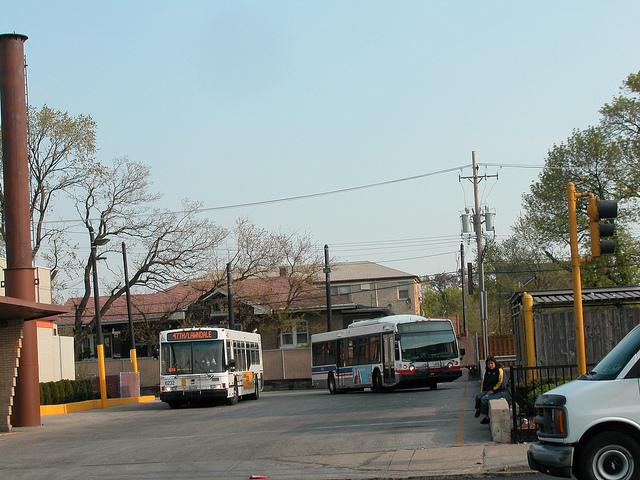Is that a tour bus?
Give a very brief answer. No. Is there a traffic warning sign in the scene?
Answer briefly. No. Is there a video store in the picture?
Be succinct. No. What is the number on the bus?
Keep it brief. 605. How many buses are there?
Be succinct. 2. What is in front of the bus?
Quick response, please. Woman. Is there a bus bench?
Answer briefly. Yes. Where is the woman?
Be succinct. Bench. 